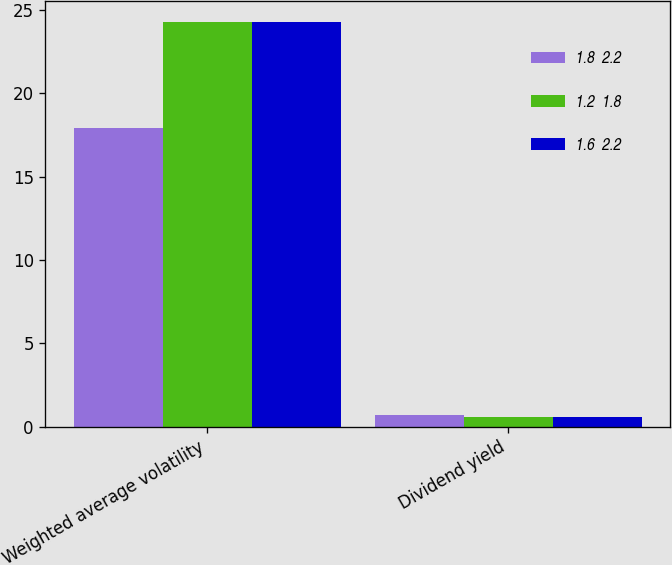Convert chart to OTSL. <chart><loc_0><loc_0><loc_500><loc_500><stacked_bar_chart><ecel><fcel>Weighted average volatility<fcel>Dividend yield<nl><fcel>1.8  2.2<fcel>17.9<fcel>0.7<nl><fcel>1.2  1.8<fcel>24.3<fcel>0.6<nl><fcel>1.6  2.2<fcel>24.3<fcel>0.6<nl></chart> 